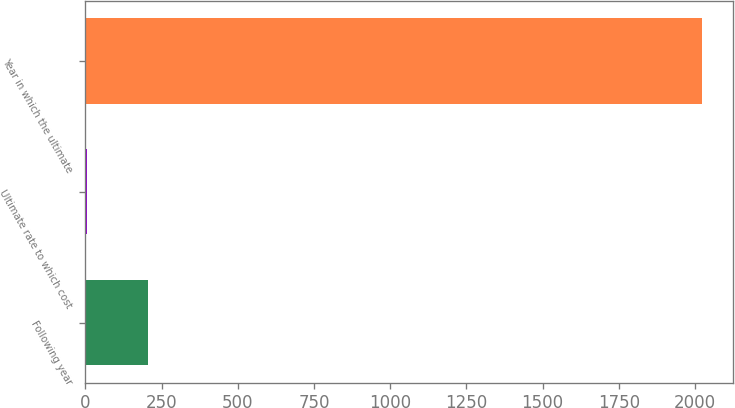<chart> <loc_0><loc_0><loc_500><loc_500><bar_chart><fcel>Following year<fcel>Ultimate rate to which cost<fcel>Year in which the ultimate<nl><fcel>206.8<fcel>5<fcel>2023<nl></chart> 